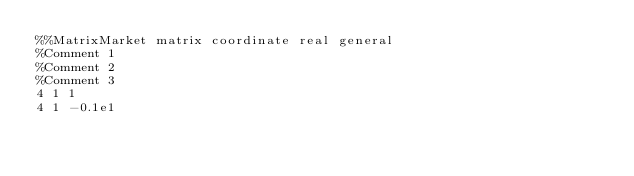Convert code to text. <code><loc_0><loc_0><loc_500><loc_500><_ObjectiveC_>%%MatrixMarket matrix coordinate real general
%Comment 1
%Comment 2
%Comment 3
4 1 1
4 1 -0.1e1
</code> 